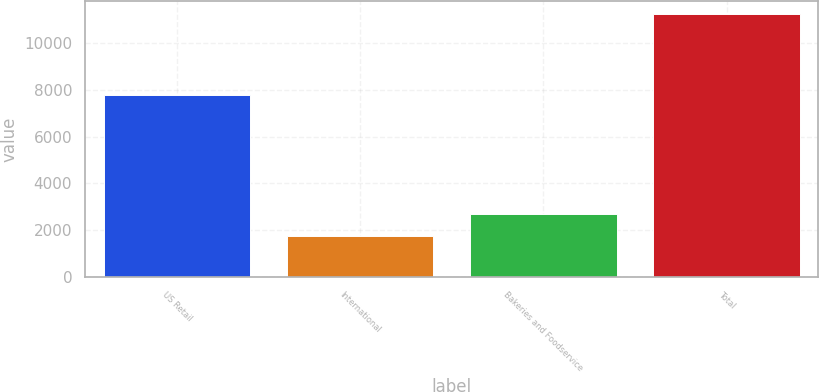<chart> <loc_0><loc_0><loc_500><loc_500><bar_chart><fcel>US Retail<fcel>International<fcel>Bakeries and Foodservice<fcel>Total<nl><fcel>7779<fcel>1725<fcel>2676.9<fcel>11244<nl></chart> 